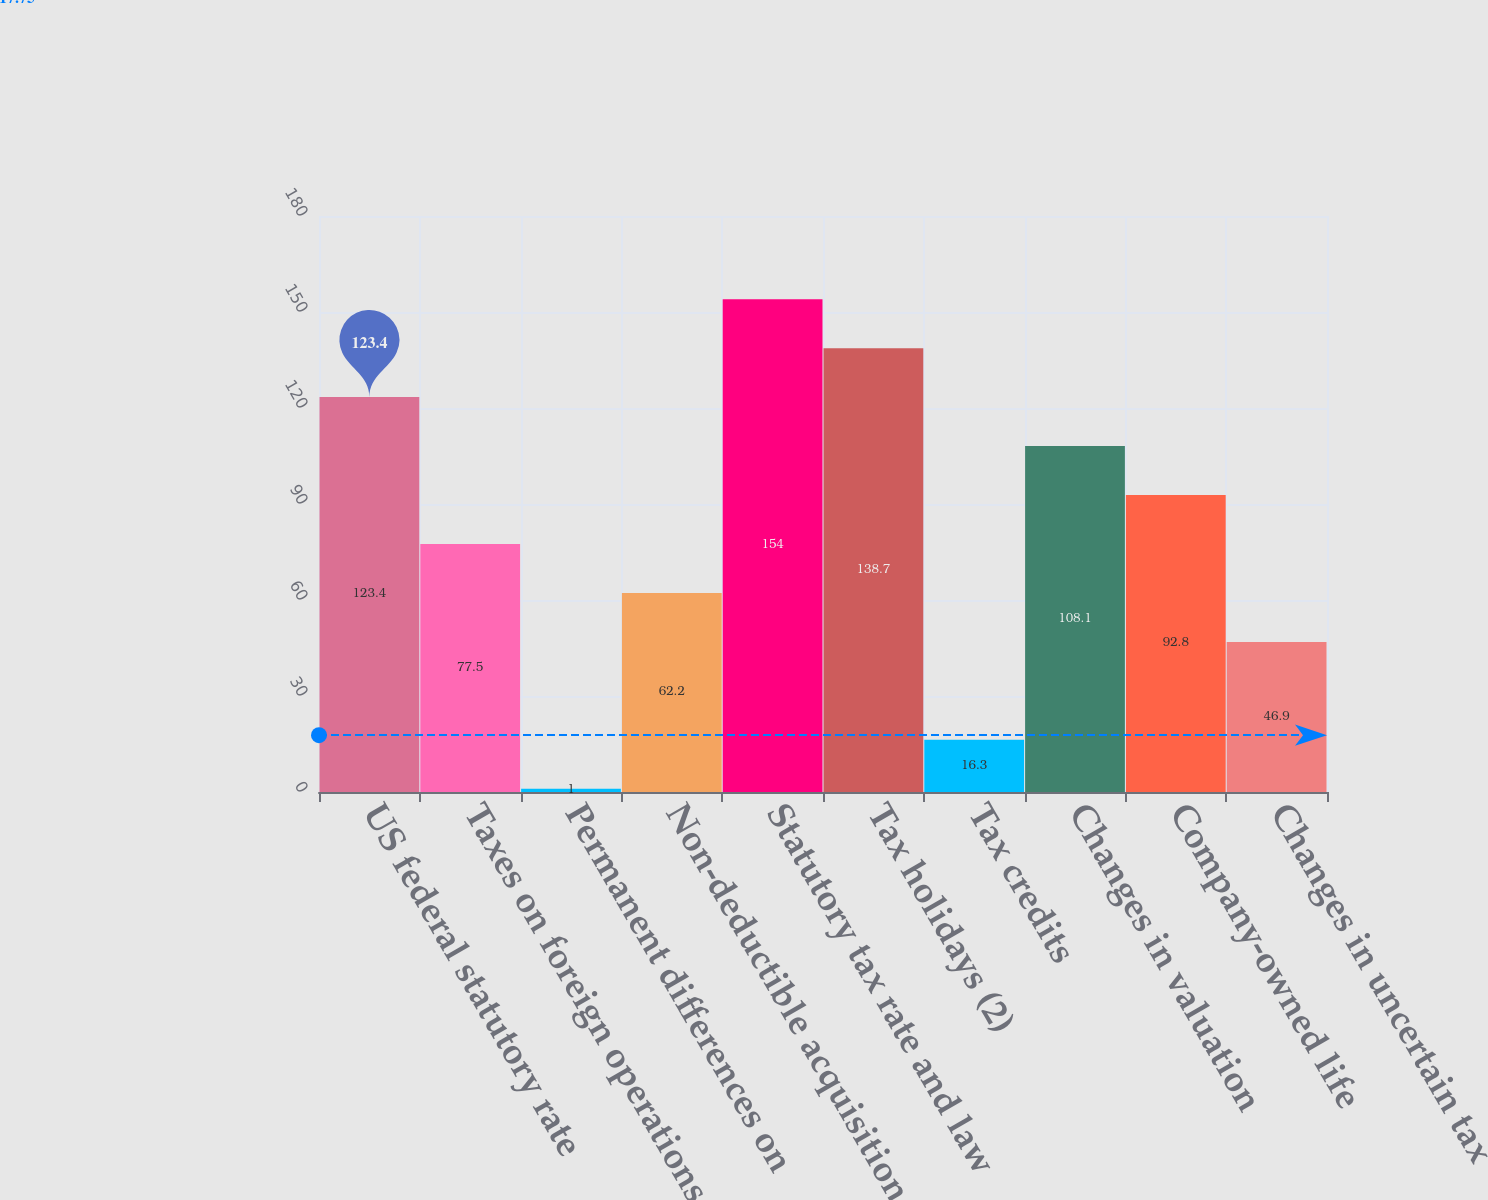<chart> <loc_0><loc_0><loc_500><loc_500><bar_chart><fcel>US federal statutory rate<fcel>Taxes on foreign operations<fcel>Permanent differences on<fcel>Non-deductible acquisition<fcel>Statutory tax rate and law<fcel>Tax holidays (2)<fcel>Tax credits<fcel>Changes in valuation<fcel>Company-owned life<fcel>Changes in uncertain tax<nl><fcel>123.4<fcel>77.5<fcel>1<fcel>62.2<fcel>154<fcel>138.7<fcel>16.3<fcel>108.1<fcel>92.8<fcel>46.9<nl></chart> 